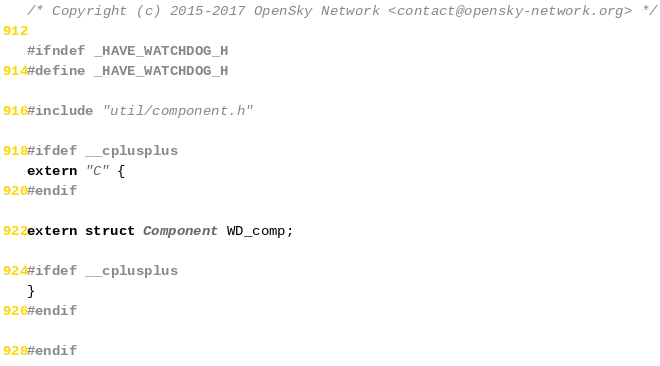Convert code to text. <code><loc_0><loc_0><loc_500><loc_500><_C_>/* Copyright (c) 2015-2017 OpenSky Network <contact@opensky-network.org> */

#ifndef _HAVE_WATCHDOG_H
#define _HAVE_WATCHDOG_H

#include "util/component.h"

#ifdef __cplusplus
extern "C" {
#endif

extern struct Component WD_comp;

#ifdef __cplusplus
}
#endif

#endif
</code> 